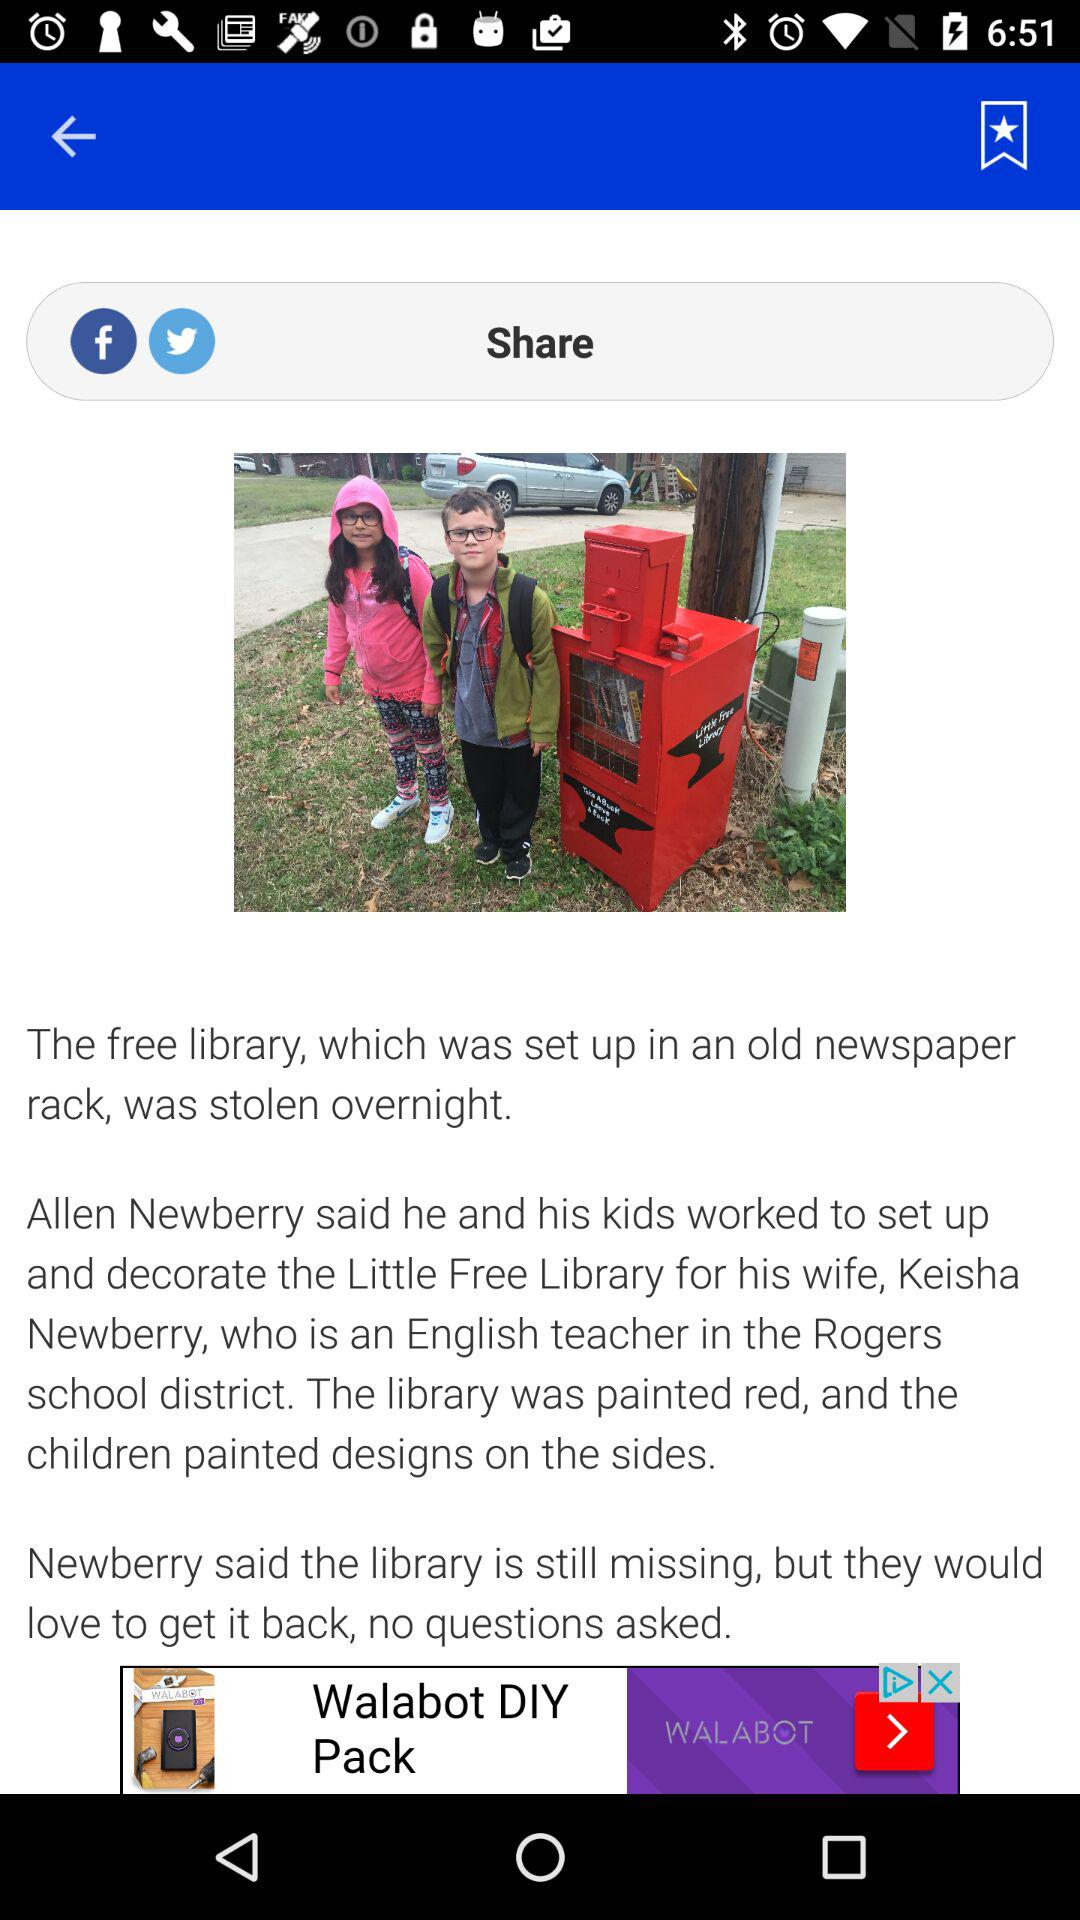What is the color of the library? The color of the library is red. 